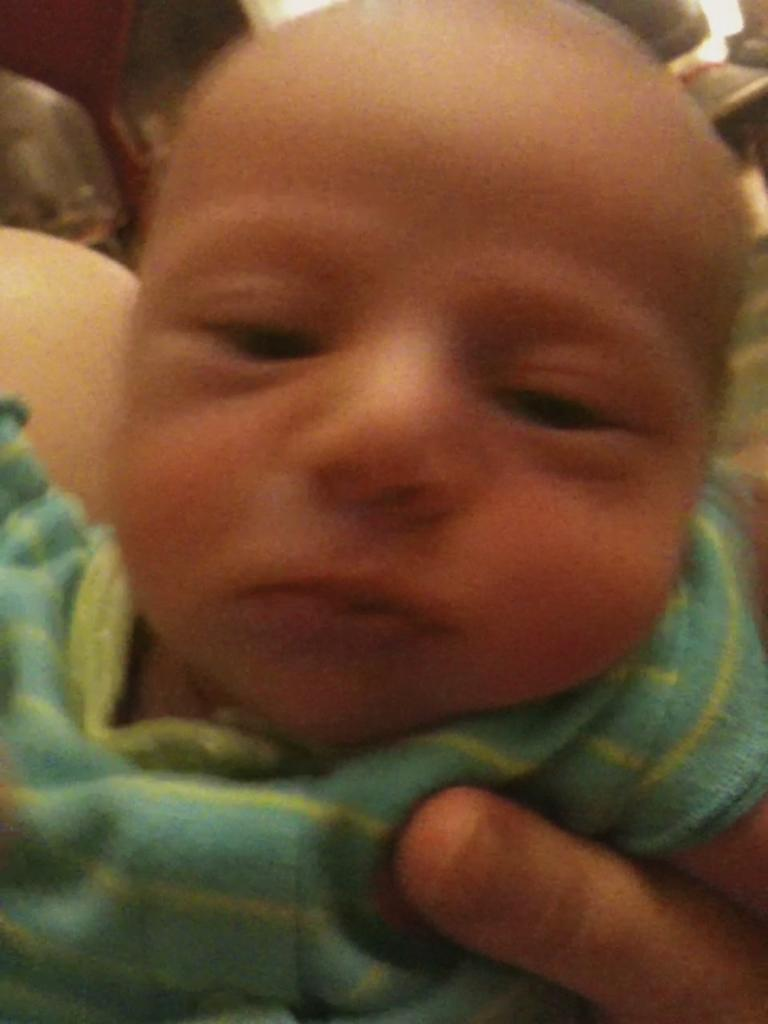What is the main subject of the picture? The main subject of the picture is a baby. What is the baby wearing in the image? The baby is wearing clothes in the image. Can you describe any other elements in the picture? There is a person's finger visible on the bottom right side of the image. How many cakes are on the baby's head in the image? There are no cakes present in the image, so it cannot be determined how many cakes might be on the baby's head. 